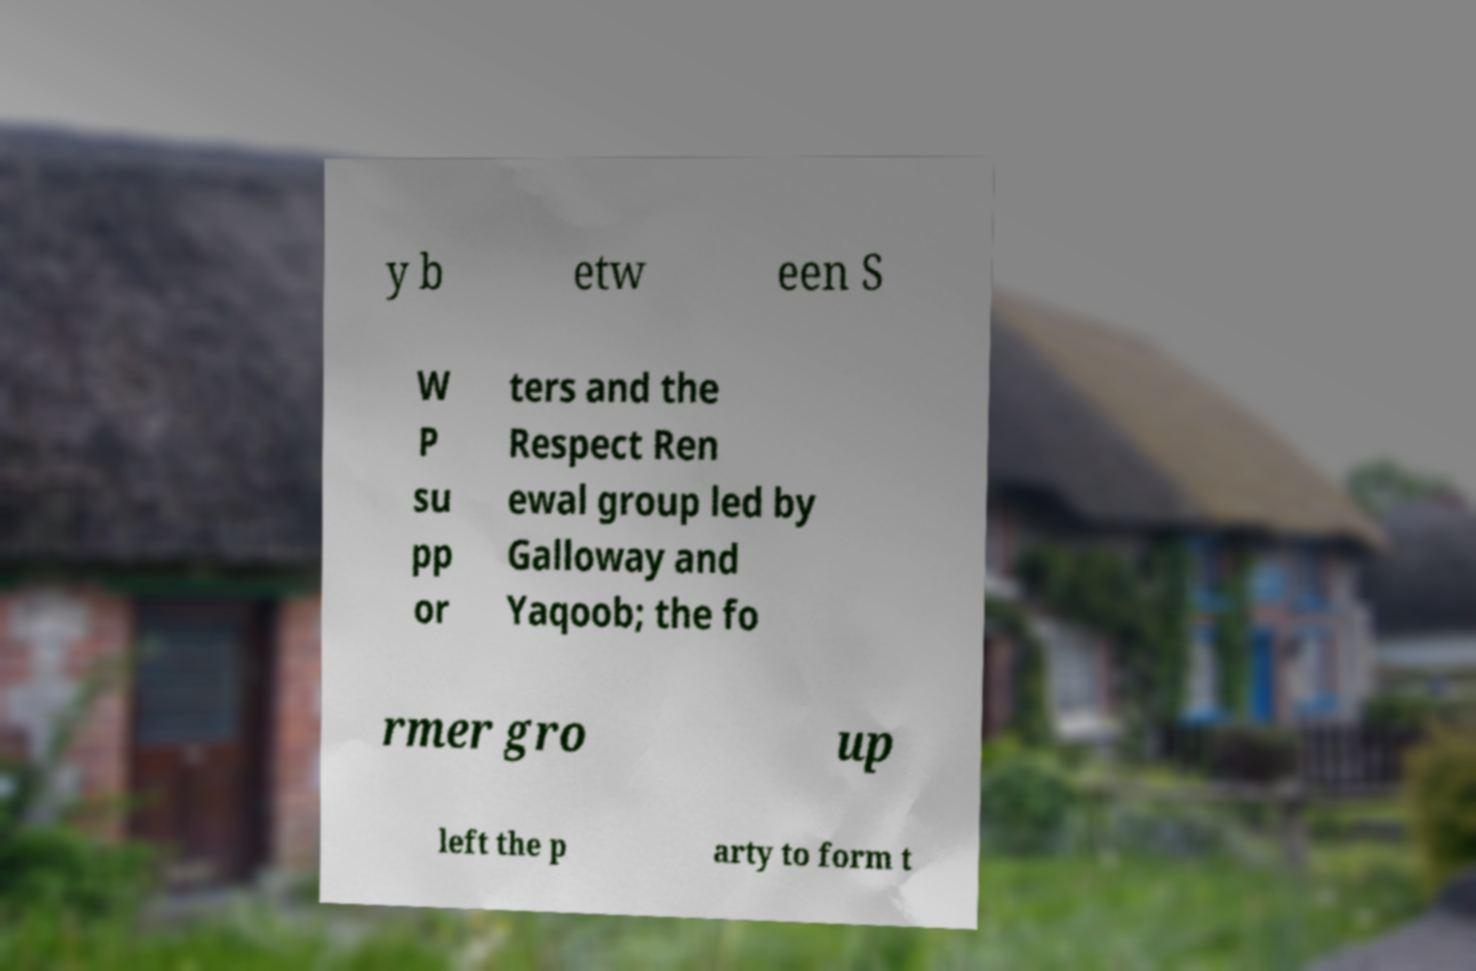There's text embedded in this image that I need extracted. Can you transcribe it verbatim? y b etw een S W P su pp or ters and the Respect Ren ewal group led by Galloway and Yaqoob; the fo rmer gro up left the p arty to form t 